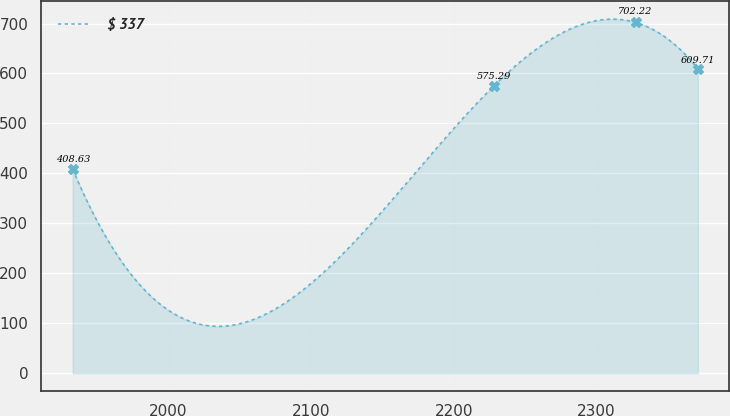Convert chart. <chart><loc_0><loc_0><loc_500><loc_500><line_chart><ecel><fcel>$ 337<nl><fcel>1932.92<fcel>408.63<nl><fcel>2228.05<fcel>575.29<nl><fcel>2327.26<fcel>702.22<nl><fcel>2370.89<fcel>609.71<nl></chart> 